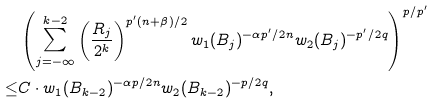<formula> <loc_0><loc_0><loc_500><loc_500>& \left ( \sum _ { j = - \infty } ^ { k - 2 } \left ( \frac { R _ { j } } { 2 ^ { k } } \right ) ^ { p ^ { \prime } ( n + \beta ) / 2 } w _ { 1 } ( B _ { j } ) ^ { - { \alpha p ^ { \prime } } / { 2 n } } w _ { 2 } ( B _ { j } ) ^ { - p ^ { \prime } / { 2 q } } \right ) ^ { p / { p ^ { \prime } } } \\ \leq & C \cdot w _ { 1 } ( B _ { k - 2 } ) ^ { - { \alpha p } / { 2 n } } w _ { 2 } ( B _ { k - 2 } ) ^ { - p / { 2 q } } ,</formula> 